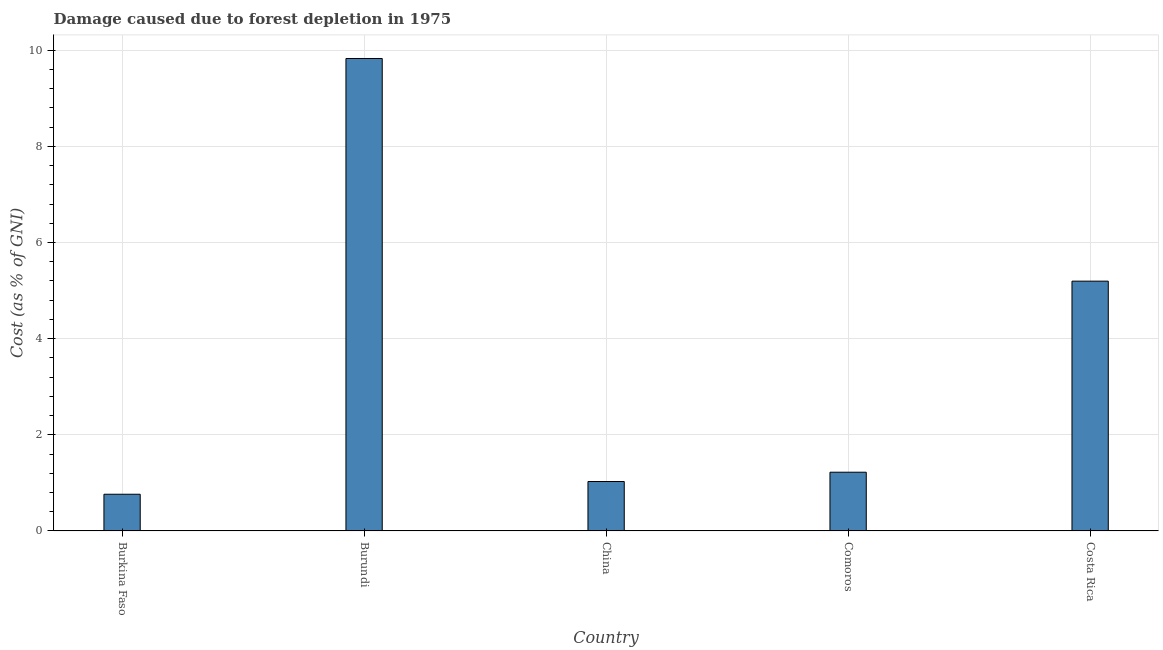Does the graph contain any zero values?
Your answer should be compact. No. Does the graph contain grids?
Ensure brevity in your answer.  Yes. What is the title of the graph?
Your response must be concise. Damage caused due to forest depletion in 1975. What is the label or title of the X-axis?
Provide a succinct answer. Country. What is the label or title of the Y-axis?
Provide a succinct answer. Cost (as % of GNI). What is the damage caused due to forest depletion in China?
Your answer should be very brief. 1.03. Across all countries, what is the maximum damage caused due to forest depletion?
Your answer should be very brief. 9.83. Across all countries, what is the minimum damage caused due to forest depletion?
Ensure brevity in your answer.  0.76. In which country was the damage caused due to forest depletion maximum?
Provide a short and direct response. Burundi. In which country was the damage caused due to forest depletion minimum?
Your answer should be compact. Burkina Faso. What is the sum of the damage caused due to forest depletion?
Your answer should be very brief. 18.04. What is the difference between the damage caused due to forest depletion in Burkina Faso and China?
Offer a terse response. -0.27. What is the average damage caused due to forest depletion per country?
Your answer should be very brief. 3.61. What is the median damage caused due to forest depletion?
Give a very brief answer. 1.22. In how many countries, is the damage caused due to forest depletion greater than 2.4 %?
Make the answer very short. 2. What is the ratio of the damage caused due to forest depletion in Burundi to that in Costa Rica?
Your answer should be very brief. 1.89. What is the difference between the highest and the second highest damage caused due to forest depletion?
Your answer should be compact. 4.63. What is the difference between the highest and the lowest damage caused due to forest depletion?
Make the answer very short. 9.06. In how many countries, is the damage caused due to forest depletion greater than the average damage caused due to forest depletion taken over all countries?
Offer a very short reply. 2. How many bars are there?
Provide a succinct answer. 5. Are all the bars in the graph horizontal?
Offer a very short reply. No. How many countries are there in the graph?
Your response must be concise. 5. What is the Cost (as % of GNI) of Burkina Faso?
Offer a very short reply. 0.76. What is the Cost (as % of GNI) of Burundi?
Give a very brief answer. 9.83. What is the Cost (as % of GNI) in China?
Your answer should be very brief. 1.03. What is the Cost (as % of GNI) of Comoros?
Provide a succinct answer. 1.22. What is the Cost (as % of GNI) in Costa Rica?
Keep it short and to the point. 5.2. What is the difference between the Cost (as % of GNI) in Burkina Faso and Burundi?
Your response must be concise. -9.06. What is the difference between the Cost (as % of GNI) in Burkina Faso and China?
Your answer should be compact. -0.27. What is the difference between the Cost (as % of GNI) in Burkina Faso and Comoros?
Your answer should be very brief. -0.46. What is the difference between the Cost (as % of GNI) in Burkina Faso and Costa Rica?
Your answer should be very brief. -4.43. What is the difference between the Cost (as % of GNI) in Burundi and China?
Give a very brief answer. 8.8. What is the difference between the Cost (as % of GNI) in Burundi and Comoros?
Offer a very short reply. 8.61. What is the difference between the Cost (as % of GNI) in Burundi and Costa Rica?
Provide a short and direct response. 4.63. What is the difference between the Cost (as % of GNI) in China and Comoros?
Offer a very short reply. -0.19. What is the difference between the Cost (as % of GNI) in China and Costa Rica?
Offer a very short reply. -4.17. What is the difference between the Cost (as % of GNI) in Comoros and Costa Rica?
Provide a short and direct response. -3.97. What is the ratio of the Cost (as % of GNI) in Burkina Faso to that in Burundi?
Provide a short and direct response. 0.08. What is the ratio of the Cost (as % of GNI) in Burkina Faso to that in China?
Your response must be concise. 0.74. What is the ratio of the Cost (as % of GNI) in Burkina Faso to that in Comoros?
Ensure brevity in your answer.  0.62. What is the ratio of the Cost (as % of GNI) in Burkina Faso to that in Costa Rica?
Your response must be concise. 0.15. What is the ratio of the Cost (as % of GNI) in Burundi to that in China?
Your response must be concise. 9.56. What is the ratio of the Cost (as % of GNI) in Burundi to that in Comoros?
Your answer should be compact. 8.04. What is the ratio of the Cost (as % of GNI) in Burundi to that in Costa Rica?
Give a very brief answer. 1.89. What is the ratio of the Cost (as % of GNI) in China to that in Comoros?
Your answer should be compact. 0.84. What is the ratio of the Cost (as % of GNI) in China to that in Costa Rica?
Give a very brief answer. 0.2. What is the ratio of the Cost (as % of GNI) in Comoros to that in Costa Rica?
Offer a very short reply. 0.23. 